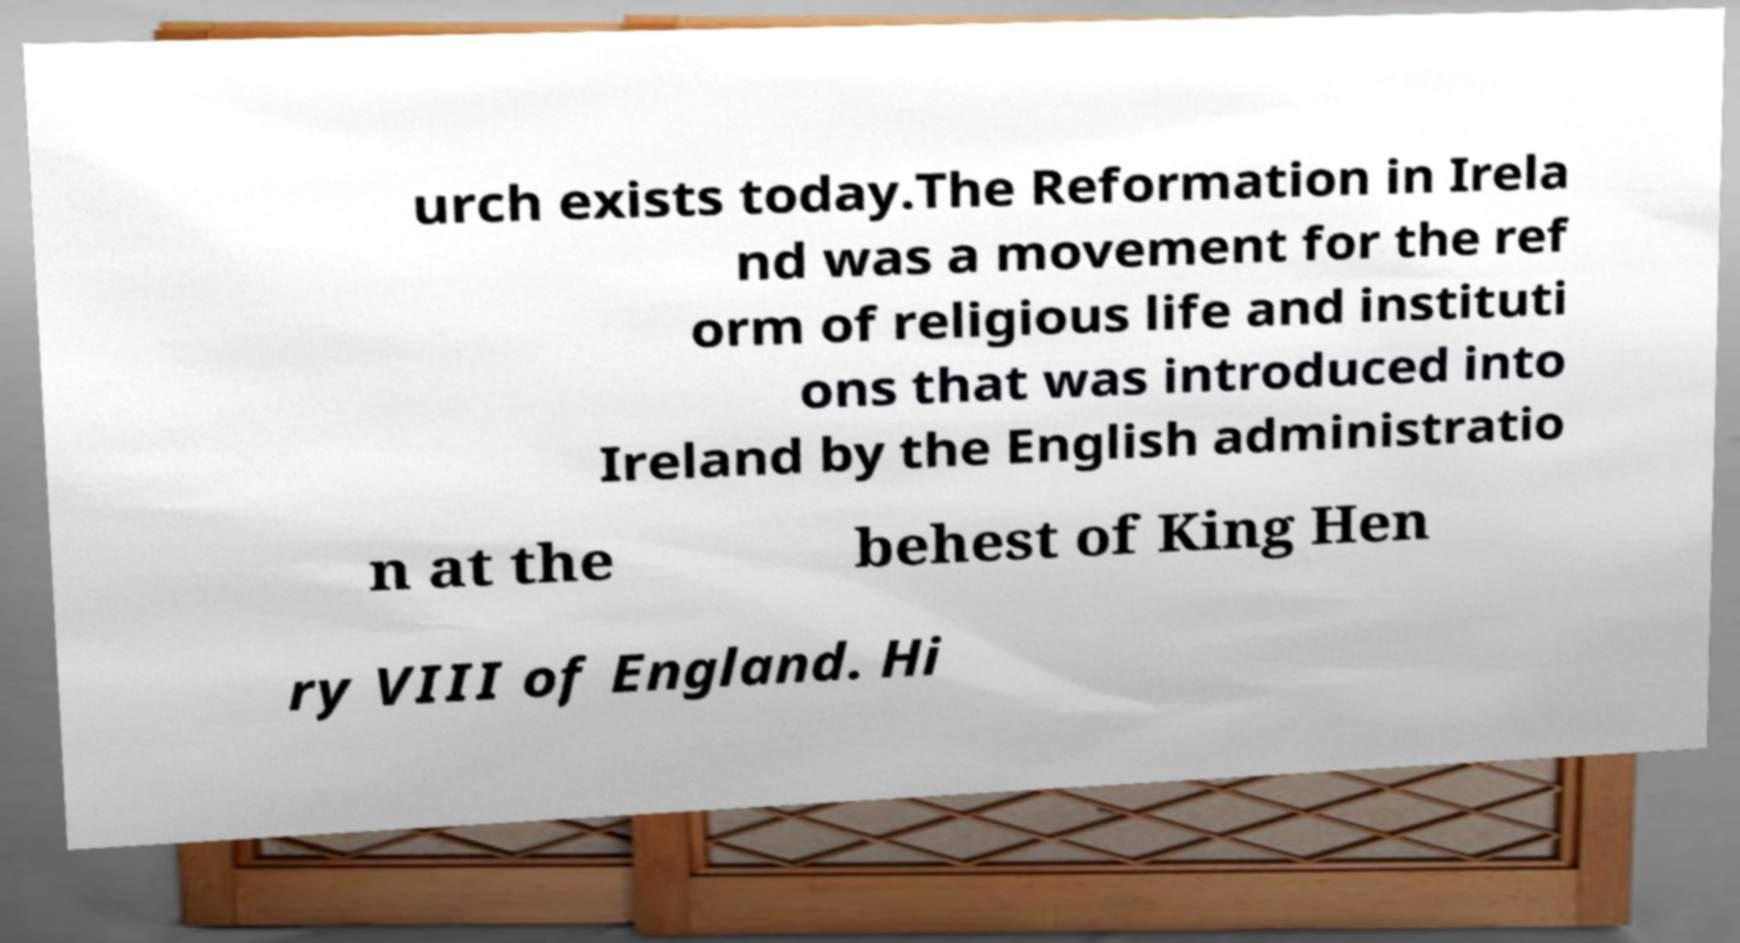I need the written content from this picture converted into text. Can you do that? urch exists today.The Reformation in Irela nd was a movement for the ref orm of religious life and instituti ons that was introduced into Ireland by the English administratio n at the behest of King Hen ry VIII of England. Hi 